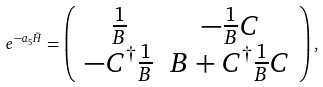<formula> <loc_0><loc_0><loc_500><loc_500>e ^ { - a _ { 5 } \tilde { H } } = \left ( \begin{array} { c c } \frac { 1 } { B } & - \frac { 1 } { B } C \\ - C ^ { \dagger } \frac { 1 } { B } & B + C ^ { \dagger } \frac { 1 } { B } C \end{array} \right ) ,</formula> 